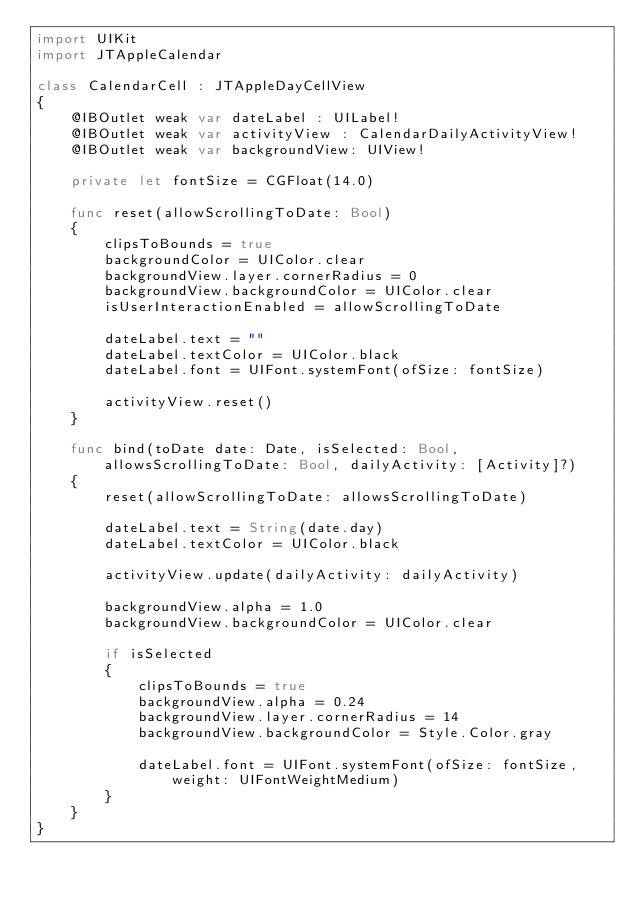<code> <loc_0><loc_0><loc_500><loc_500><_Swift_>import UIKit
import JTAppleCalendar

class CalendarCell : JTAppleDayCellView
{
    @IBOutlet weak var dateLabel : UILabel!
    @IBOutlet weak var activityView : CalendarDailyActivityView!
    @IBOutlet weak var backgroundView: UIView!
    
    private let fontSize = CGFloat(14.0)
    
    func reset(allowScrollingToDate: Bool)
    {
        clipsToBounds = true
        backgroundColor = UIColor.clear
        backgroundView.layer.cornerRadius = 0
        backgroundView.backgroundColor = UIColor.clear
        isUserInteractionEnabled = allowScrollingToDate
        
        dateLabel.text = ""
        dateLabel.textColor = UIColor.black
        dateLabel.font = UIFont.systemFont(ofSize: fontSize)
        
        activityView.reset()
    }
    
    func bind(toDate date: Date, isSelected: Bool, allowsScrollingToDate: Bool, dailyActivity: [Activity]?)
    {
        reset(allowScrollingToDate: allowsScrollingToDate)
        
        dateLabel.text = String(date.day)
        dateLabel.textColor = UIColor.black
        
        activityView.update(dailyActivity: dailyActivity)
        
        backgroundView.alpha = 1.0
        backgroundView.backgroundColor = UIColor.clear
        
        if isSelected
        {
            clipsToBounds = true
            backgroundView.alpha = 0.24
            backgroundView.layer.cornerRadius = 14
            backgroundView.backgroundColor = Style.Color.gray

            dateLabel.font = UIFont.systemFont(ofSize: fontSize, weight: UIFontWeightMedium)
        }
    }
}
</code> 